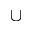Convert formula to latex. <formula><loc_0><loc_0><loc_500><loc_500>\cup</formula> 